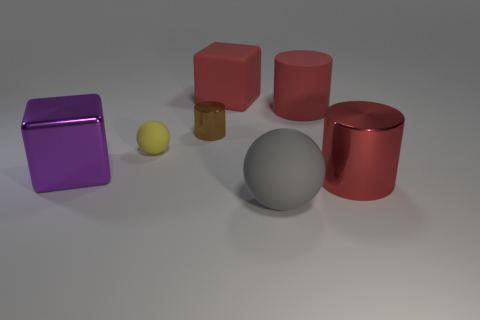Add 1 gray rubber cylinders. How many objects exist? 8 Subtract all balls. How many objects are left? 5 Subtract 0 brown cubes. How many objects are left? 7 Subtract all matte cubes. Subtract all red rubber cylinders. How many objects are left? 5 Add 6 blocks. How many blocks are left? 8 Add 4 big yellow shiny cylinders. How many big yellow shiny cylinders exist? 4 